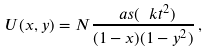Convert formula to latex. <formula><loc_0><loc_0><loc_500><loc_500>U ( x , y ) = N \frac { \ a s ( \ k t ^ { 2 } ) } { ( 1 - x ) ( 1 - y ^ { 2 } ) } \, ,</formula> 